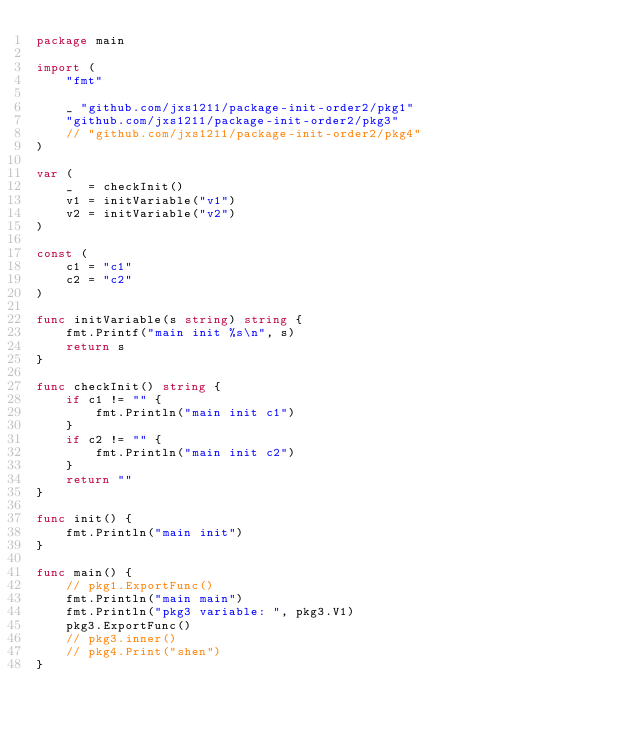<code> <loc_0><loc_0><loc_500><loc_500><_Go_>package main

import (
	"fmt"

	_ "github.com/jxs1211/package-init-order2/pkg1"
	"github.com/jxs1211/package-init-order2/pkg3"
	// "github.com/jxs1211/package-init-order2/pkg4"
)

var (
	_  = checkInit()
	v1 = initVariable("v1")
	v2 = initVariable("v2")
)

const (
	c1 = "c1"
	c2 = "c2"
)

func initVariable(s string) string {
	fmt.Printf("main init %s\n", s)
	return s
}

func checkInit() string {
	if c1 != "" {
		fmt.Println("main init c1")
	}
	if c2 != "" {
		fmt.Println("main init c2")
	}
	return ""
}

func init() {
	fmt.Println("main init")
}

func main() {
	// pkg1.ExportFunc()
	fmt.Println("main main")
	fmt.Println("pkg3 variable: ", pkg3.V1)
	pkg3.ExportFunc()
	// pkg3.inner()
	// pkg4.Print("shen")
}
</code> 